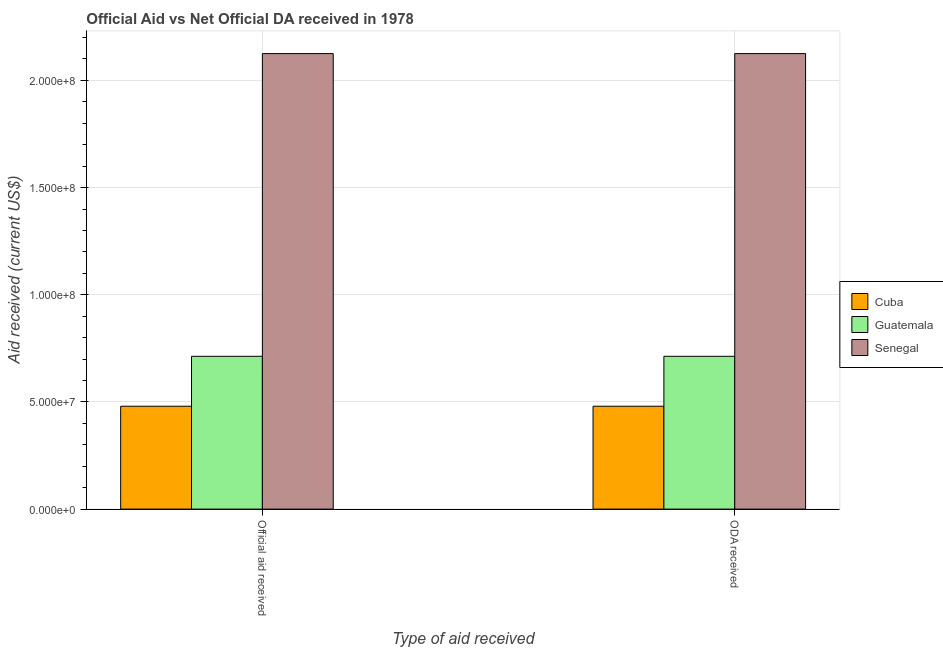How many different coloured bars are there?
Offer a very short reply. 3. How many bars are there on the 1st tick from the left?
Offer a very short reply. 3. What is the label of the 2nd group of bars from the left?
Provide a succinct answer. ODA received. What is the oda received in Cuba?
Keep it short and to the point. 4.80e+07. Across all countries, what is the maximum official aid received?
Ensure brevity in your answer.  2.12e+08. Across all countries, what is the minimum official aid received?
Your response must be concise. 4.80e+07. In which country was the official aid received maximum?
Provide a short and direct response. Senegal. In which country was the oda received minimum?
Keep it short and to the point. Cuba. What is the total official aid received in the graph?
Your answer should be very brief. 3.32e+08. What is the difference between the official aid received in Cuba and that in Senegal?
Offer a terse response. -1.65e+08. What is the difference between the official aid received in Senegal and the oda received in Cuba?
Give a very brief answer. 1.65e+08. What is the average official aid received per country?
Provide a short and direct response. 1.11e+08. What is the difference between the oda received and official aid received in Cuba?
Offer a terse response. 0. What is the ratio of the official aid received in Guatemala to that in Senegal?
Offer a terse response. 0.34. What does the 2nd bar from the left in ODA received represents?
Provide a succinct answer. Guatemala. What does the 2nd bar from the right in Official aid received represents?
Provide a short and direct response. Guatemala. What is the difference between two consecutive major ticks on the Y-axis?
Ensure brevity in your answer.  5.00e+07. How are the legend labels stacked?
Give a very brief answer. Vertical. What is the title of the graph?
Make the answer very short. Official Aid vs Net Official DA received in 1978 . Does "Euro area" appear as one of the legend labels in the graph?
Provide a succinct answer. No. What is the label or title of the X-axis?
Your response must be concise. Type of aid received. What is the label or title of the Y-axis?
Ensure brevity in your answer.  Aid received (current US$). What is the Aid received (current US$) of Cuba in Official aid received?
Ensure brevity in your answer.  4.80e+07. What is the Aid received (current US$) of Guatemala in Official aid received?
Make the answer very short. 7.13e+07. What is the Aid received (current US$) of Senegal in Official aid received?
Keep it short and to the point. 2.12e+08. What is the Aid received (current US$) of Cuba in ODA received?
Give a very brief answer. 4.80e+07. What is the Aid received (current US$) in Guatemala in ODA received?
Ensure brevity in your answer.  7.13e+07. What is the Aid received (current US$) in Senegal in ODA received?
Provide a short and direct response. 2.12e+08. Across all Type of aid received, what is the maximum Aid received (current US$) in Cuba?
Make the answer very short. 4.80e+07. Across all Type of aid received, what is the maximum Aid received (current US$) in Guatemala?
Offer a terse response. 7.13e+07. Across all Type of aid received, what is the maximum Aid received (current US$) of Senegal?
Keep it short and to the point. 2.12e+08. Across all Type of aid received, what is the minimum Aid received (current US$) of Cuba?
Provide a short and direct response. 4.80e+07. Across all Type of aid received, what is the minimum Aid received (current US$) in Guatemala?
Provide a succinct answer. 7.13e+07. Across all Type of aid received, what is the minimum Aid received (current US$) in Senegal?
Make the answer very short. 2.12e+08. What is the total Aid received (current US$) in Cuba in the graph?
Ensure brevity in your answer.  9.60e+07. What is the total Aid received (current US$) in Guatemala in the graph?
Provide a succinct answer. 1.43e+08. What is the total Aid received (current US$) in Senegal in the graph?
Offer a terse response. 4.25e+08. What is the difference between the Aid received (current US$) in Cuba in Official aid received and that in ODA received?
Keep it short and to the point. 0. What is the difference between the Aid received (current US$) in Cuba in Official aid received and the Aid received (current US$) in Guatemala in ODA received?
Make the answer very short. -2.33e+07. What is the difference between the Aid received (current US$) in Cuba in Official aid received and the Aid received (current US$) in Senegal in ODA received?
Your answer should be very brief. -1.65e+08. What is the difference between the Aid received (current US$) in Guatemala in Official aid received and the Aid received (current US$) in Senegal in ODA received?
Make the answer very short. -1.41e+08. What is the average Aid received (current US$) of Cuba per Type of aid received?
Offer a terse response. 4.80e+07. What is the average Aid received (current US$) in Guatemala per Type of aid received?
Give a very brief answer. 7.13e+07. What is the average Aid received (current US$) in Senegal per Type of aid received?
Make the answer very short. 2.12e+08. What is the difference between the Aid received (current US$) of Cuba and Aid received (current US$) of Guatemala in Official aid received?
Your response must be concise. -2.33e+07. What is the difference between the Aid received (current US$) of Cuba and Aid received (current US$) of Senegal in Official aid received?
Your response must be concise. -1.65e+08. What is the difference between the Aid received (current US$) of Guatemala and Aid received (current US$) of Senegal in Official aid received?
Offer a very short reply. -1.41e+08. What is the difference between the Aid received (current US$) of Cuba and Aid received (current US$) of Guatemala in ODA received?
Your response must be concise. -2.33e+07. What is the difference between the Aid received (current US$) of Cuba and Aid received (current US$) of Senegal in ODA received?
Give a very brief answer. -1.65e+08. What is the difference between the Aid received (current US$) of Guatemala and Aid received (current US$) of Senegal in ODA received?
Keep it short and to the point. -1.41e+08. What is the ratio of the Aid received (current US$) of Guatemala in Official aid received to that in ODA received?
Give a very brief answer. 1. What is the ratio of the Aid received (current US$) in Senegal in Official aid received to that in ODA received?
Provide a short and direct response. 1. What is the difference between the highest and the second highest Aid received (current US$) in Senegal?
Give a very brief answer. 0. What is the difference between the highest and the lowest Aid received (current US$) of Cuba?
Ensure brevity in your answer.  0. What is the difference between the highest and the lowest Aid received (current US$) of Senegal?
Your response must be concise. 0. 